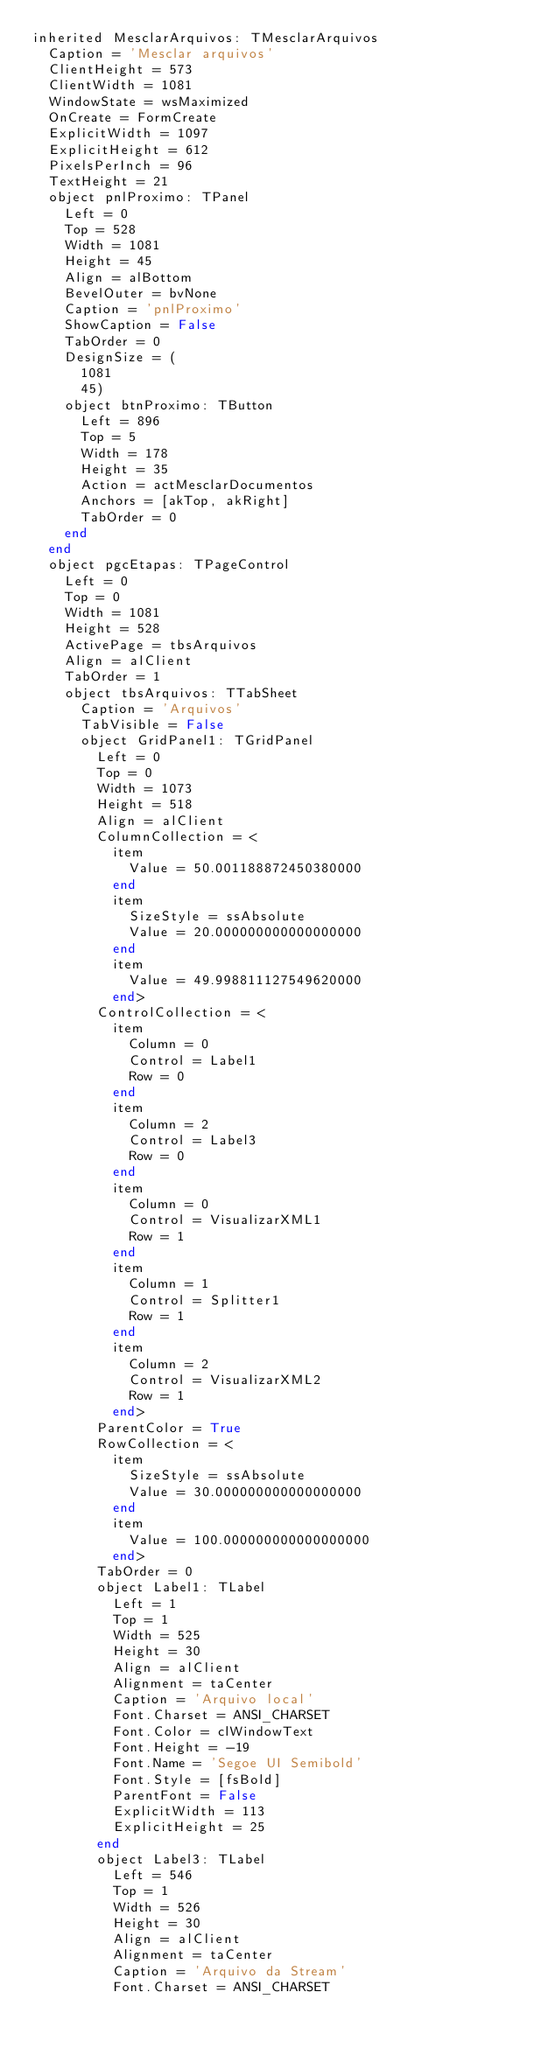<code> <loc_0><loc_0><loc_500><loc_500><_Pascal_>inherited MesclarArquivos: TMesclarArquivos
  Caption = 'Mesclar arquivos'
  ClientHeight = 573
  ClientWidth = 1081
  WindowState = wsMaximized
  OnCreate = FormCreate
  ExplicitWidth = 1097
  ExplicitHeight = 612
  PixelsPerInch = 96
  TextHeight = 21
  object pnlProximo: TPanel
    Left = 0
    Top = 528
    Width = 1081
    Height = 45
    Align = alBottom
    BevelOuter = bvNone
    Caption = 'pnlProximo'
    ShowCaption = False
    TabOrder = 0
    DesignSize = (
      1081
      45)
    object btnProximo: TButton
      Left = 896
      Top = 5
      Width = 178
      Height = 35
      Action = actMesclarDocumentos
      Anchors = [akTop, akRight]
      TabOrder = 0
    end
  end
  object pgcEtapas: TPageControl
    Left = 0
    Top = 0
    Width = 1081
    Height = 528
    ActivePage = tbsArquivos
    Align = alClient
    TabOrder = 1
    object tbsArquivos: TTabSheet
      Caption = 'Arquivos'
      TabVisible = False
      object GridPanel1: TGridPanel
        Left = 0
        Top = 0
        Width = 1073
        Height = 518
        Align = alClient
        ColumnCollection = <
          item
            Value = 50.001188872450380000
          end
          item
            SizeStyle = ssAbsolute
            Value = 20.000000000000000000
          end
          item
            Value = 49.998811127549620000
          end>
        ControlCollection = <
          item
            Column = 0
            Control = Label1
            Row = 0
          end
          item
            Column = 2
            Control = Label3
            Row = 0
          end
          item
            Column = 0
            Control = VisualizarXML1
            Row = 1
          end
          item
            Column = 1
            Control = Splitter1
            Row = 1
          end
          item
            Column = 2
            Control = VisualizarXML2
            Row = 1
          end>
        ParentColor = True
        RowCollection = <
          item
            SizeStyle = ssAbsolute
            Value = 30.000000000000000000
          end
          item
            Value = 100.000000000000000000
          end>
        TabOrder = 0
        object Label1: TLabel
          Left = 1
          Top = 1
          Width = 525
          Height = 30
          Align = alClient
          Alignment = taCenter
          Caption = 'Arquivo local'
          Font.Charset = ANSI_CHARSET
          Font.Color = clWindowText
          Font.Height = -19
          Font.Name = 'Segoe UI Semibold'
          Font.Style = [fsBold]
          ParentFont = False
          ExplicitWidth = 113
          ExplicitHeight = 25
        end
        object Label3: TLabel
          Left = 546
          Top = 1
          Width = 526
          Height = 30
          Align = alClient
          Alignment = taCenter
          Caption = 'Arquivo da Stream'
          Font.Charset = ANSI_CHARSET</code> 